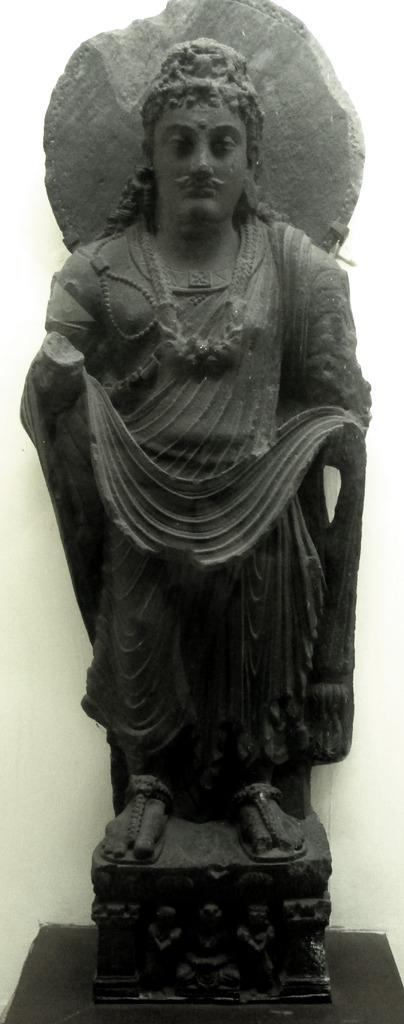Please provide a concise description of this image. This image consists of a sculpture made up of rock kept on the desk. It is in black color. In the background, there is a wall. 